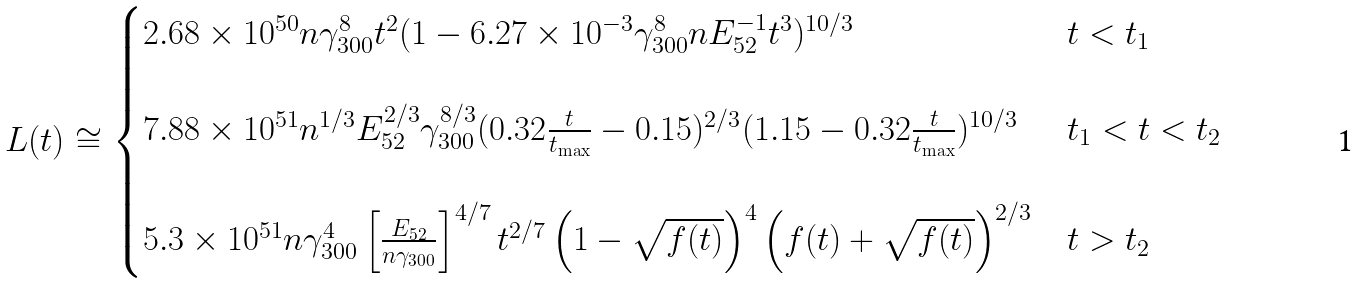<formula> <loc_0><loc_0><loc_500><loc_500>L ( t ) \cong \begin{cases} 2 . 6 8 \times 1 0 ^ { 5 0 } n \gamma _ { 3 0 0 } ^ { 8 } t ^ { 2 } ( { 1 - { 6 . 2 7 \times 1 0 ^ { - 3 } } \gamma _ { 3 0 0 } ^ { 8 } n E ^ { - 1 } _ { 5 2 } t ^ { 3 } } ) ^ { 1 0 / 3 } & t < t _ { 1 } \\ \\ 7 . 8 8 \times 1 0 ^ { 5 1 } n ^ { 1 / 3 } E _ { 5 2 } ^ { 2 / 3 } \gamma ^ { 8 / 3 } _ { 3 0 0 } ( 0 . 3 2 \frac { t } { t _ { \max } } - 0 . 1 5 ) ^ { 2 / 3 } ( 1 . 1 5 - 0 . 3 2 \frac { t } { t _ { \max } } ) ^ { 1 0 / 3 } & t _ { 1 } < t < t _ { 2 } \\ \\ 5 . 3 \times 1 0 ^ { 5 1 } n \gamma _ { 3 0 0 } ^ { 4 } \left [ \frac { E _ { 5 2 } } { n \gamma _ { 3 0 0 } } \right ] ^ { 4 / 7 } t ^ { 2 / 7 } \left ( 1 - \sqrt { f ( t ) } \right ) ^ { 4 } { \left ( { f ( t ) + \sqrt { f ( t ) } } \right ) ^ { 2 / 3 } } & t > t _ { 2 } \end{cases}</formula> 